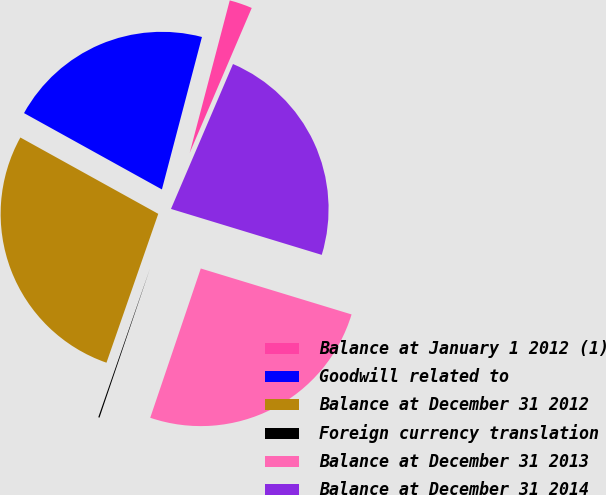Convert chart. <chart><loc_0><loc_0><loc_500><loc_500><pie_chart><fcel>Balance at January 1 2012 (1)<fcel>Goodwill related to<fcel>Balance at December 31 2012<fcel>Foreign currency translation<fcel>Balance at December 31 2013<fcel>Balance at December 31 2014<nl><fcel>2.35%<fcel>21.04%<fcel>27.72%<fcel>0.13%<fcel>25.49%<fcel>23.27%<nl></chart> 